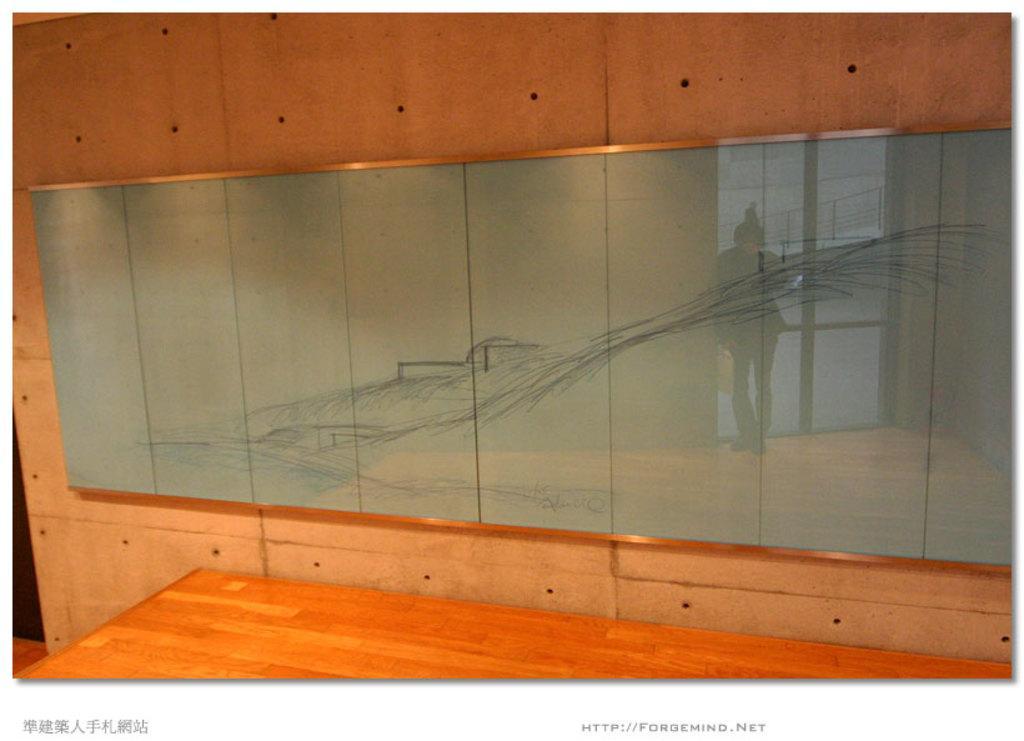Describe this image in one or two sentences. In this picture we can see a table, glass board on the wall and on this glass board we can see a reflection of a person standing on the floor, fence, doors. 